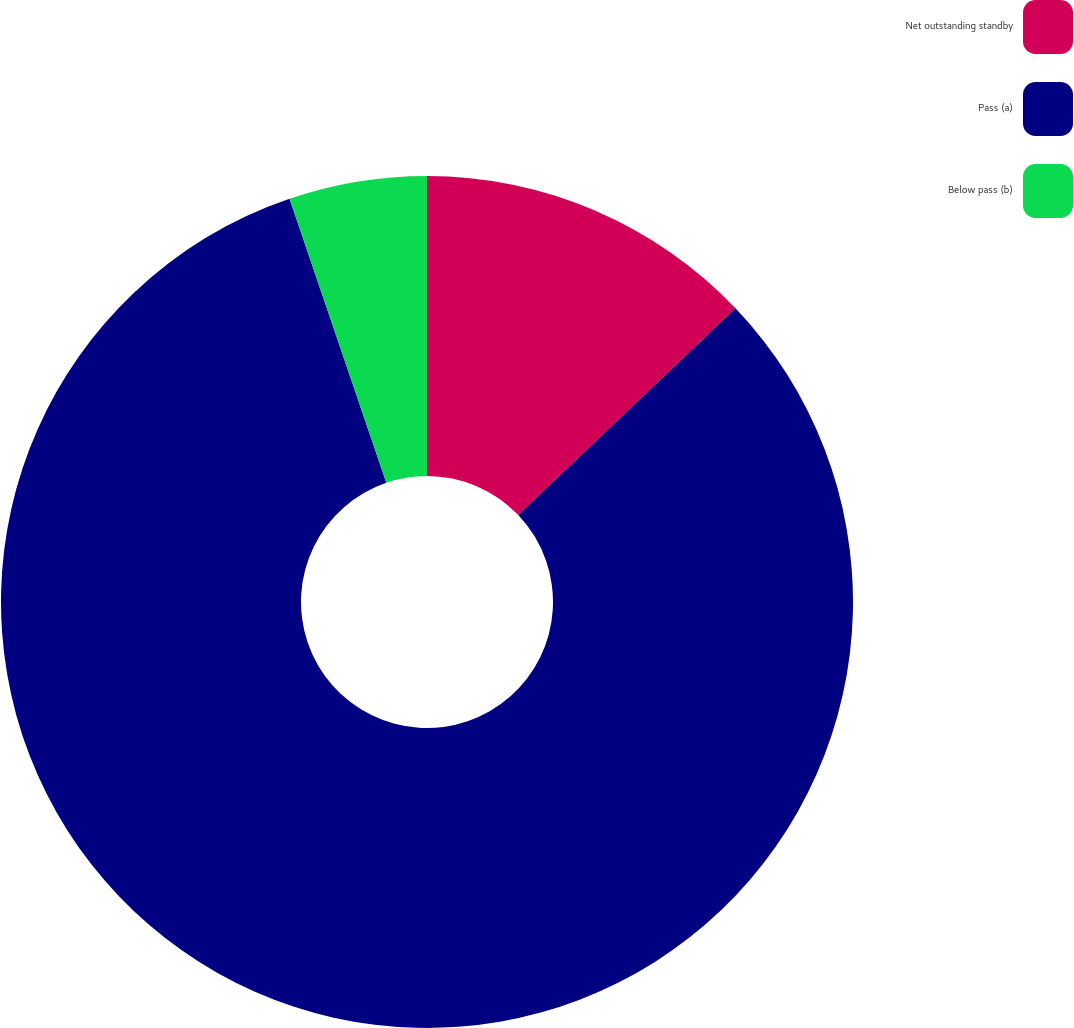Convert chart. <chart><loc_0><loc_0><loc_500><loc_500><pie_chart><fcel>Net outstanding standby<fcel>Pass (a)<fcel>Below pass (b)<nl><fcel>12.89%<fcel>81.88%<fcel>5.23%<nl></chart> 